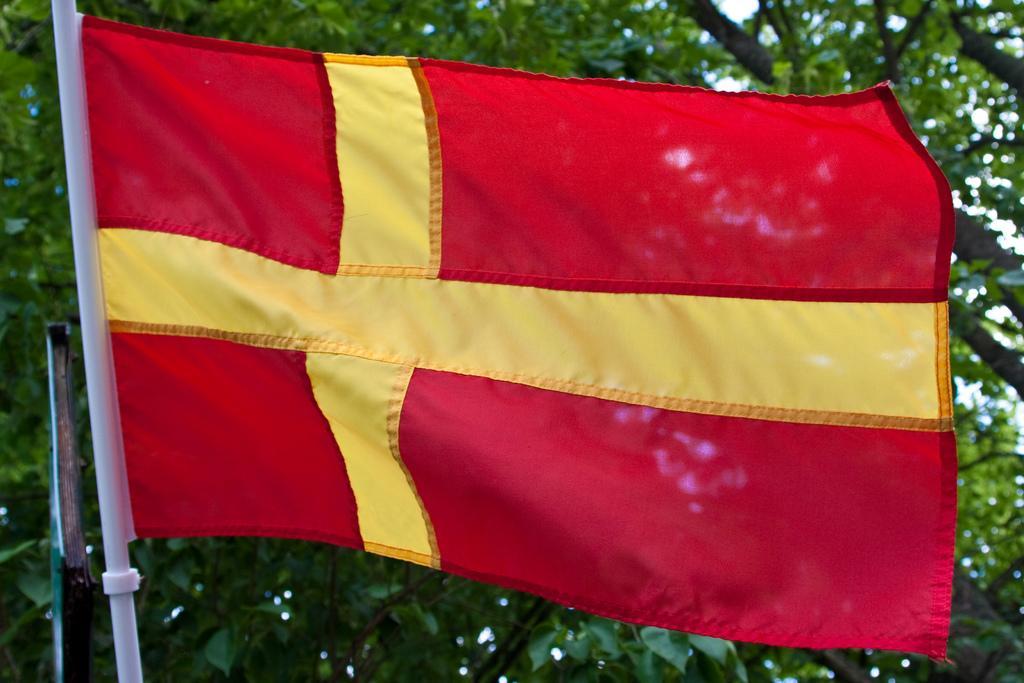In one or two sentences, can you explain what this image depicts? Here we can see a flag. In the background there are trees. 